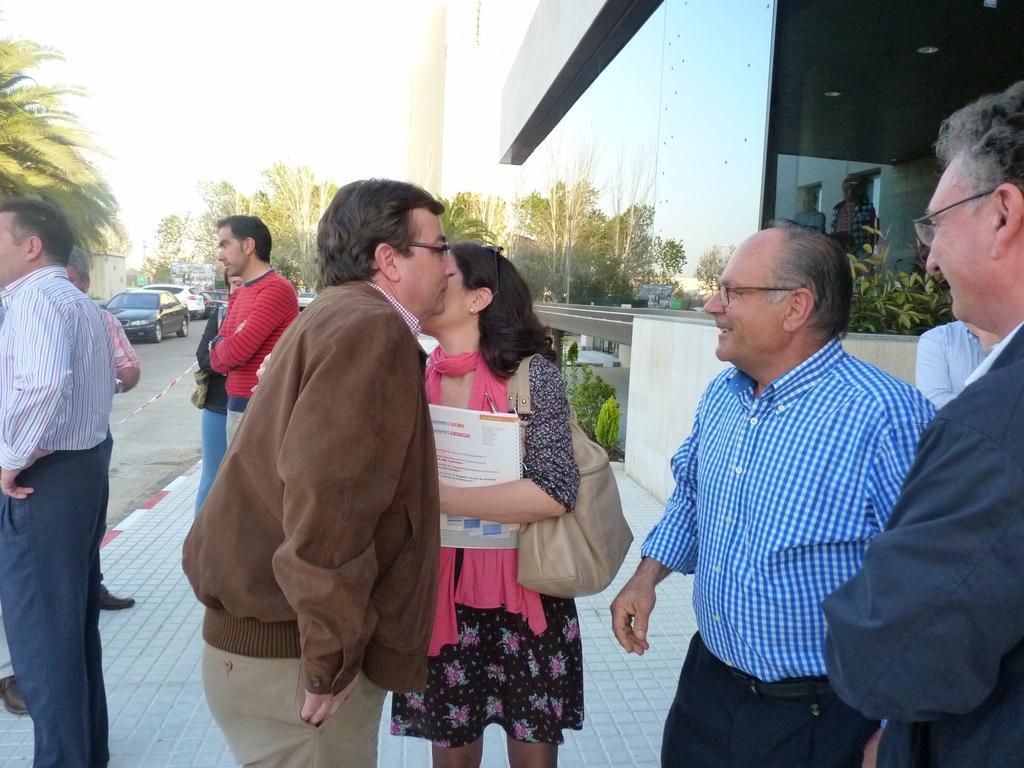Describe this image in one or two sentences. In the image there are a group of people standing beside the building on a path and among them a woman is holding some books and wearing a bag, in the background there are trees and vehicles. 